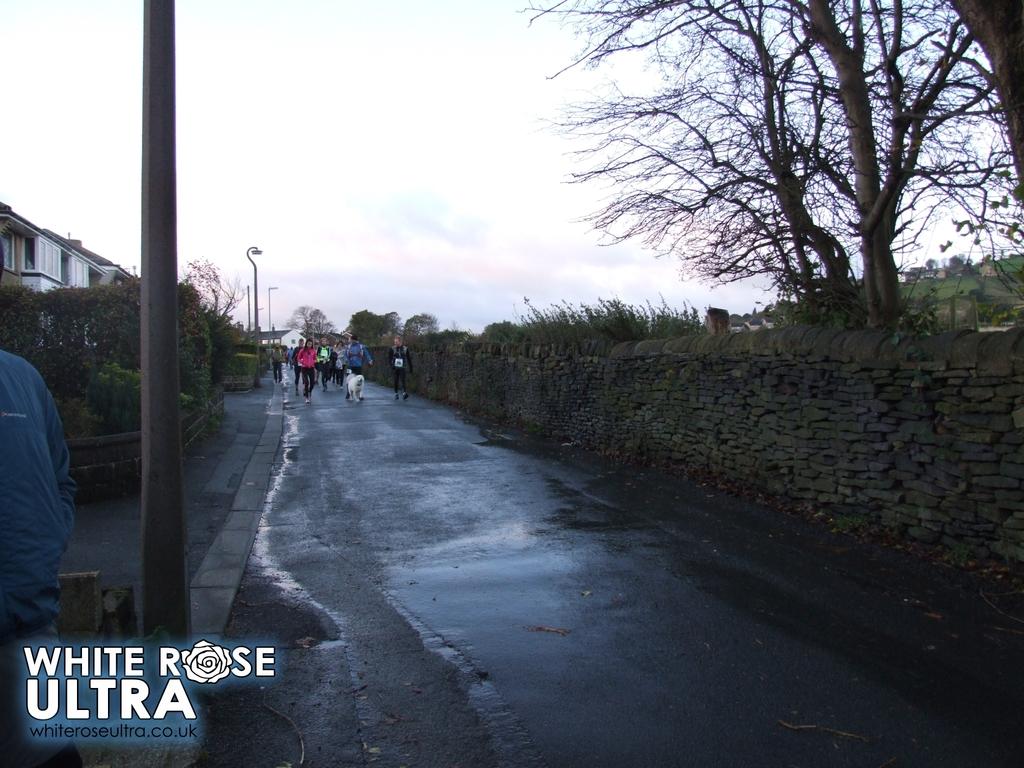What is the website in the corner of this picture?
Your answer should be very brief. Whiteroseultra.co.uk. What color is over "ultra?"?
Provide a short and direct response. White. 